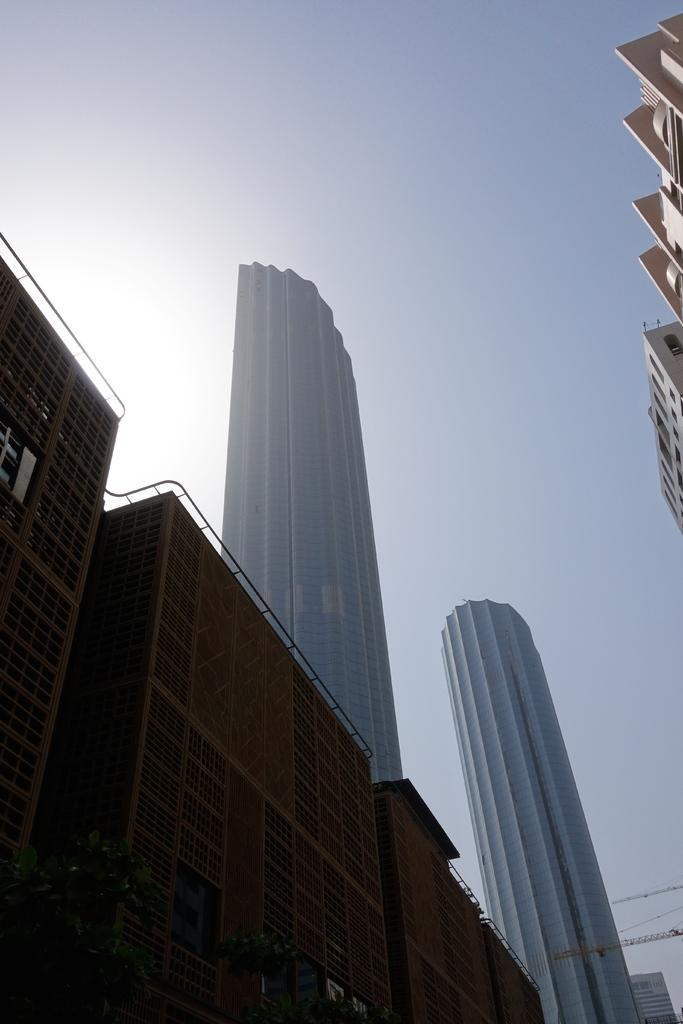What type of structures can be seen in the image? There are buildings in the image. What color is the sky in the image? The sky is blue in the image. What type of pleasure can be seen enjoying a cabbage in the image? There is no pleasure or cabbage present in the image; it only features buildings and a blue sky. How is the whip being used in the image? There is no whip present in the image. 